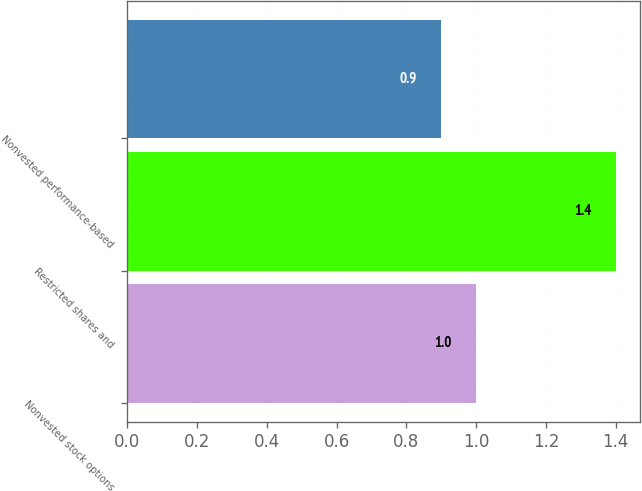Convert chart. <chart><loc_0><loc_0><loc_500><loc_500><bar_chart><fcel>Nonvested stock options<fcel>Restricted shares and<fcel>Nonvested performance-based<nl><fcel>1<fcel>1.4<fcel>0.9<nl></chart> 